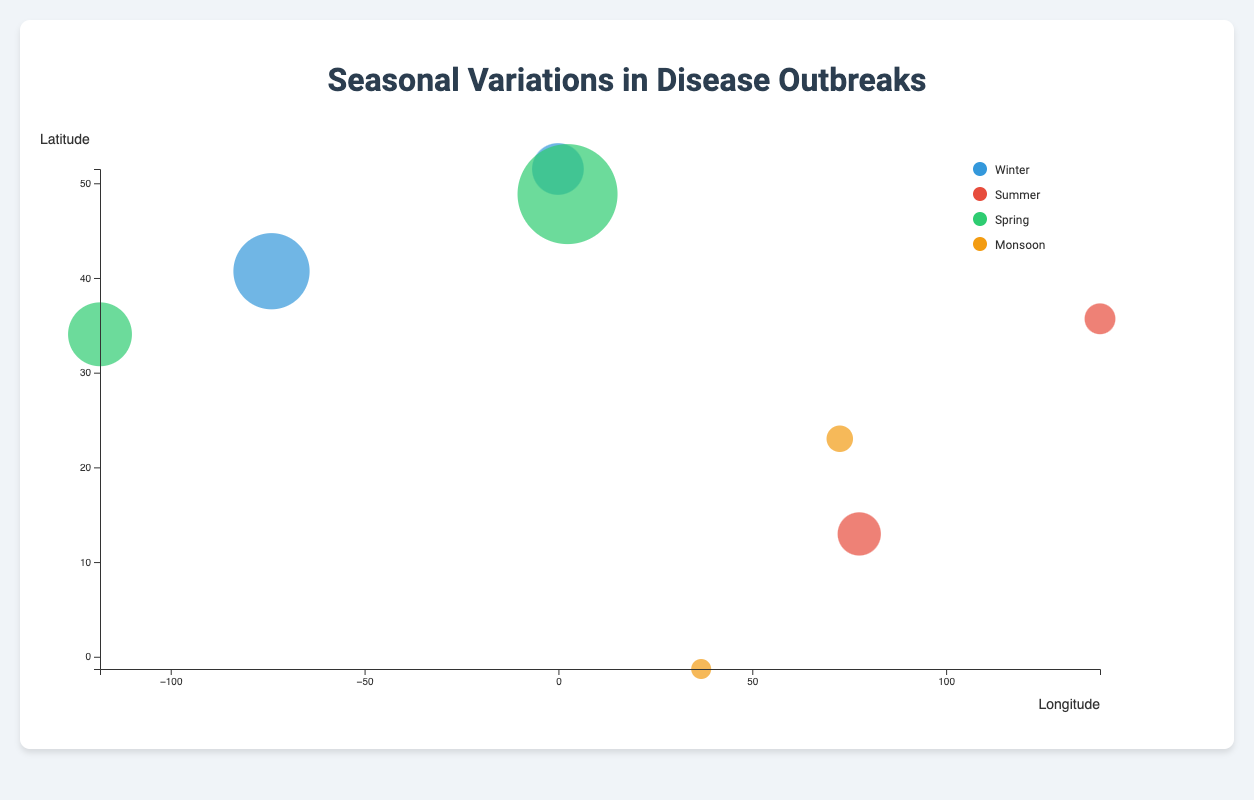what is the title of the figure? The title is presented at the top center of the figure.
Answer: Seasonal Variations in Disease Outbreaks Which season has the highest incidence rate for any disease? The bubble chart uses different colors for different seasons, and the size of the bubbles represents the incidence rate. The largest bubble corresponds to Hay Fever in Spring with an incidence rate of 150.9.
Answer: Spring How does the incidence rate of Influenza in Winter compare to that of Heat Stroke in Summer? The incidence rate of Influenza is represented by a larger bubble size (120.5) compared to Heat Stroke in Summer (62.4), indicating that Influenza has a higher incidence rate.
Answer: Influenza is higher Which disease is represented by the largest bubble? The bubble chart shows the largest bubble corresponding to the disease with the highest incidence rate. The largest bubble corresponds to Hay Fever.
Answer: Hay Fever What diseases are tracked using Air Quality sensors, and what are their respective incidence rates? By examining the labels and corresponding bubbles' size and color, Influenza in Winter has an incidence rate of 120.5, and Pneumonia in Winter has an incidence rate of 89.1.
Answer: Influenza (120.5), Pneumonia (89.1) What's the average incidence rate for diseases occurring in Summer? The diseases with incidence rates in Summer are Dengue (78.3) and Heat Stroke (62.4). The average is calculated as (78.3 + 62.4) / 2.
Answer: 70.35 Which location (latitude and longitude) represents the highest incidence rate of disease, and what is the disease? The bubble chart indicates that the largest bubble (highest incidence rate) is located at Paris (48.8566, 2.3522), corresponding to Hay Fever in Spring.
Answer: 48.8566, 2.3522 (Hay Fever) How many diseases have an incidence rate greater than 100? By checking the size of the bubbles, we find three diseases: Influenza (120.5), Asthma (104.7), and Hay Fever (150.9).
Answer: Three (3) What's the relationship between season and disease incidence rate in the figure? The colors of the bubbles represent different seasons, and sizes indicate incidence rates. Higher incidence rates correspond to Spring and Winter, and lower rates to Summer and Monsoon.
Answer: Higher in Spring and Winter Compare the incidence rates of diseases detected by "Temperature & Humidity" sensors and identify which disease has a higher rate. The diseases detected by "Temperature & Humidity" sensors are Dengue (78.3) and Heat Stroke (62.4). Dengue has a higher incidence rate.
Answer: Dengue 